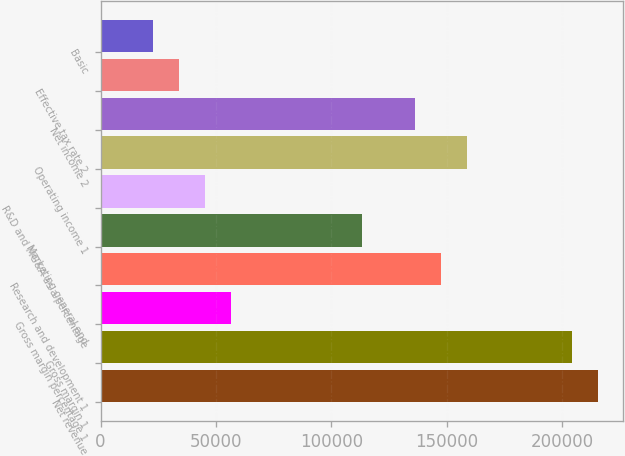Convert chart. <chart><loc_0><loc_0><loc_500><loc_500><bar_chart><fcel>Net revenue<fcel>Gross margin 1<fcel>Gross margin percentage 1<fcel>Research and development 1<fcel>Marketing general and<fcel>R&D and MG&A as a percentage<fcel>Operating income 1<fcel>Net income 2<fcel>Effective tax rate 2<fcel>Basic<nl><fcel>215320<fcel>203988<fcel>56664<fcel>147325<fcel>113327<fcel>45331.4<fcel>158657<fcel>135992<fcel>33998.8<fcel>22666.2<nl></chart> 